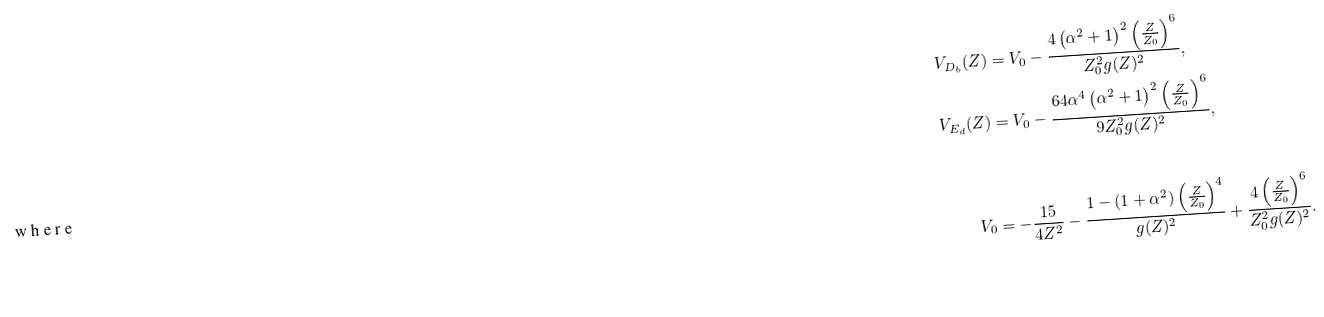Convert formula to latex. <formula><loc_0><loc_0><loc_500><loc_500>V _ { D _ { b } } ( Z ) & = V _ { 0 } - \frac { 4 \left ( \alpha ^ { 2 } + 1 \right ) ^ { 2 } \left ( \frac { Z } { Z _ { 0 } } \right ) ^ { 6 } } { Z _ { 0 } ^ { 2 } g ( Z ) ^ { 2 } } , \\ V _ { E _ { d } } ( Z ) & = V _ { 0 } - \frac { 6 4 \alpha ^ { 4 } \left ( \alpha ^ { 2 } + 1 \right ) ^ { 2 } \left ( \frac { Z } { Z _ { 0 } } \right ) ^ { 6 } } { 9 Z _ { 0 } ^ { 2 } g ( Z ) ^ { 2 } } , \\ \intertext { w h e r e } V _ { 0 } & = - \frac { 1 5 } { 4 Z ^ { 2 } } - \frac { 1 - ( 1 + \alpha ^ { 2 } ) \left ( \frac { Z } { Z _ { 0 } } \right ) ^ { 4 } } { g ( Z ) ^ { 2 } } + \frac { 4 \left ( \frac { Z } { Z _ { 0 } } \right ) ^ { 6 } } { Z _ { 0 } ^ { 2 } g ( Z ) ^ { 2 } } .</formula> 